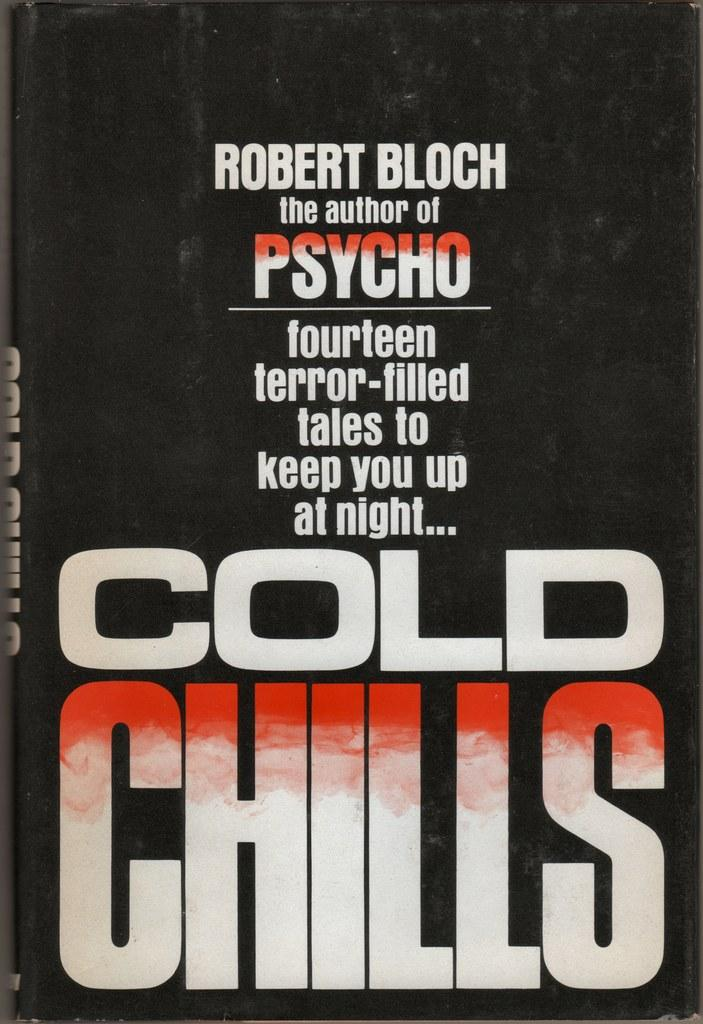What is the main subject of the image? There is a black object in the image. What does the object resemble? The object resembles a book. What can be seen on the surface of the object? There is text written on the object. Where are the dolls located in the image? There are no dolls present in the image. What is the mother doing in the image? There is no mother or any human figure present in the image. 